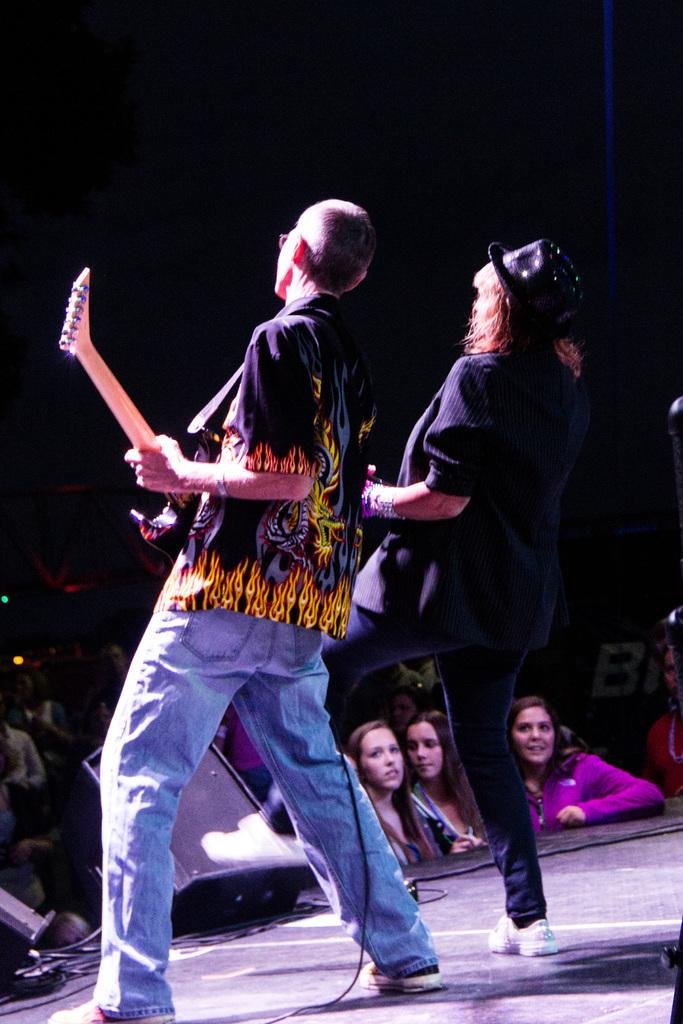Who are the people in the image? There is a man and a woman in the image. What are the man and woman doing in the image? The man and woman are playing the guitar. Who is watching the man and woman play the guitar? A: There is an audience in front of them. What type of selection is the man making with his whistle in the image? There is no whistle present in the image, and therefore no selection can be made with it. 